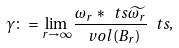<formula> <loc_0><loc_0><loc_500><loc_500>\gamma \colon = \lim _ { r \to \infty } \frac { \omega _ { r } * \ t s \widetilde { \omega _ { r } } } { \ v o l ( B _ { r } ) } \ t s ,</formula> 